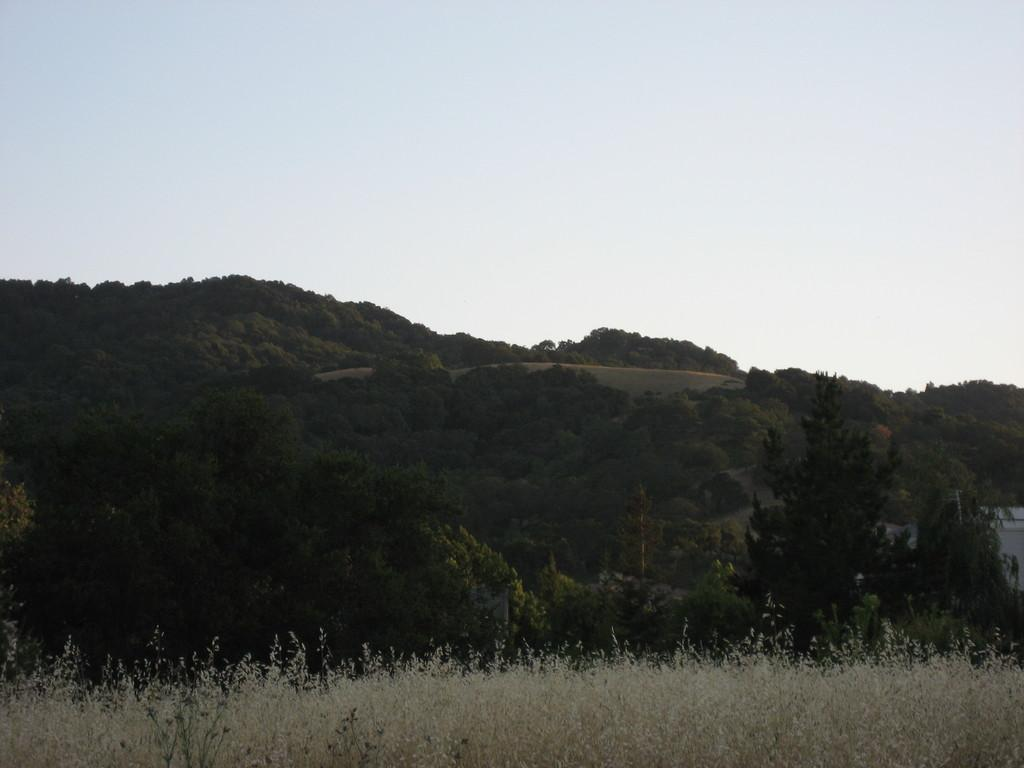What type of vegetation can be seen in the image? There are trees in the image. What part of the natural environment is visible in the image? The sky is visible in the background of the image. How many rabbits can be seen in the image? There are no rabbits present in the image. What message is being conveyed by the doll in the image? There is no doll present in the image. 